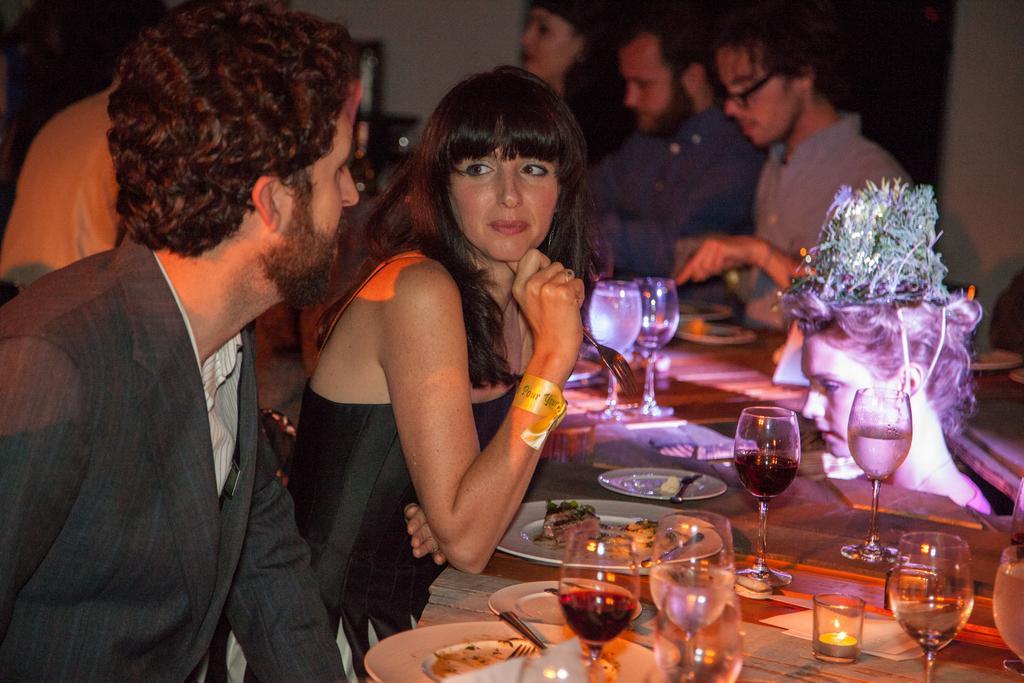Could you give a brief overview of what you see in this image? In this image we can see one women and men are sitting. They are wearing black color dress. In front of them table is there. On table glasses, plates, spoons, fork, candle and food are present. Behind them people are sitting. Right side of the image one girl statue is there on the table. 